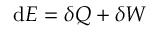<formula> <loc_0><loc_0><loc_500><loc_500>d E = \delta Q + \delta W</formula> 